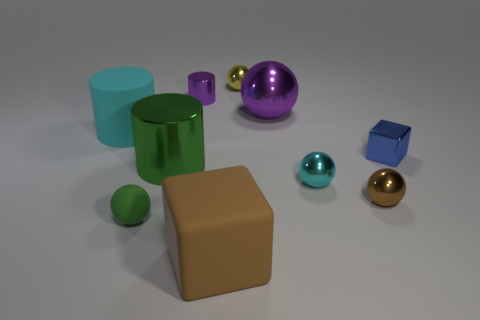Subtract all cubes. How many objects are left? 8 Add 6 yellow metal balls. How many yellow metal balls are left? 7 Add 7 tiny cyan things. How many tiny cyan things exist? 8 Subtract 0 blue cylinders. How many objects are left? 10 Subtract all large red metallic blocks. Subtract all large green shiny cylinders. How many objects are left? 9 